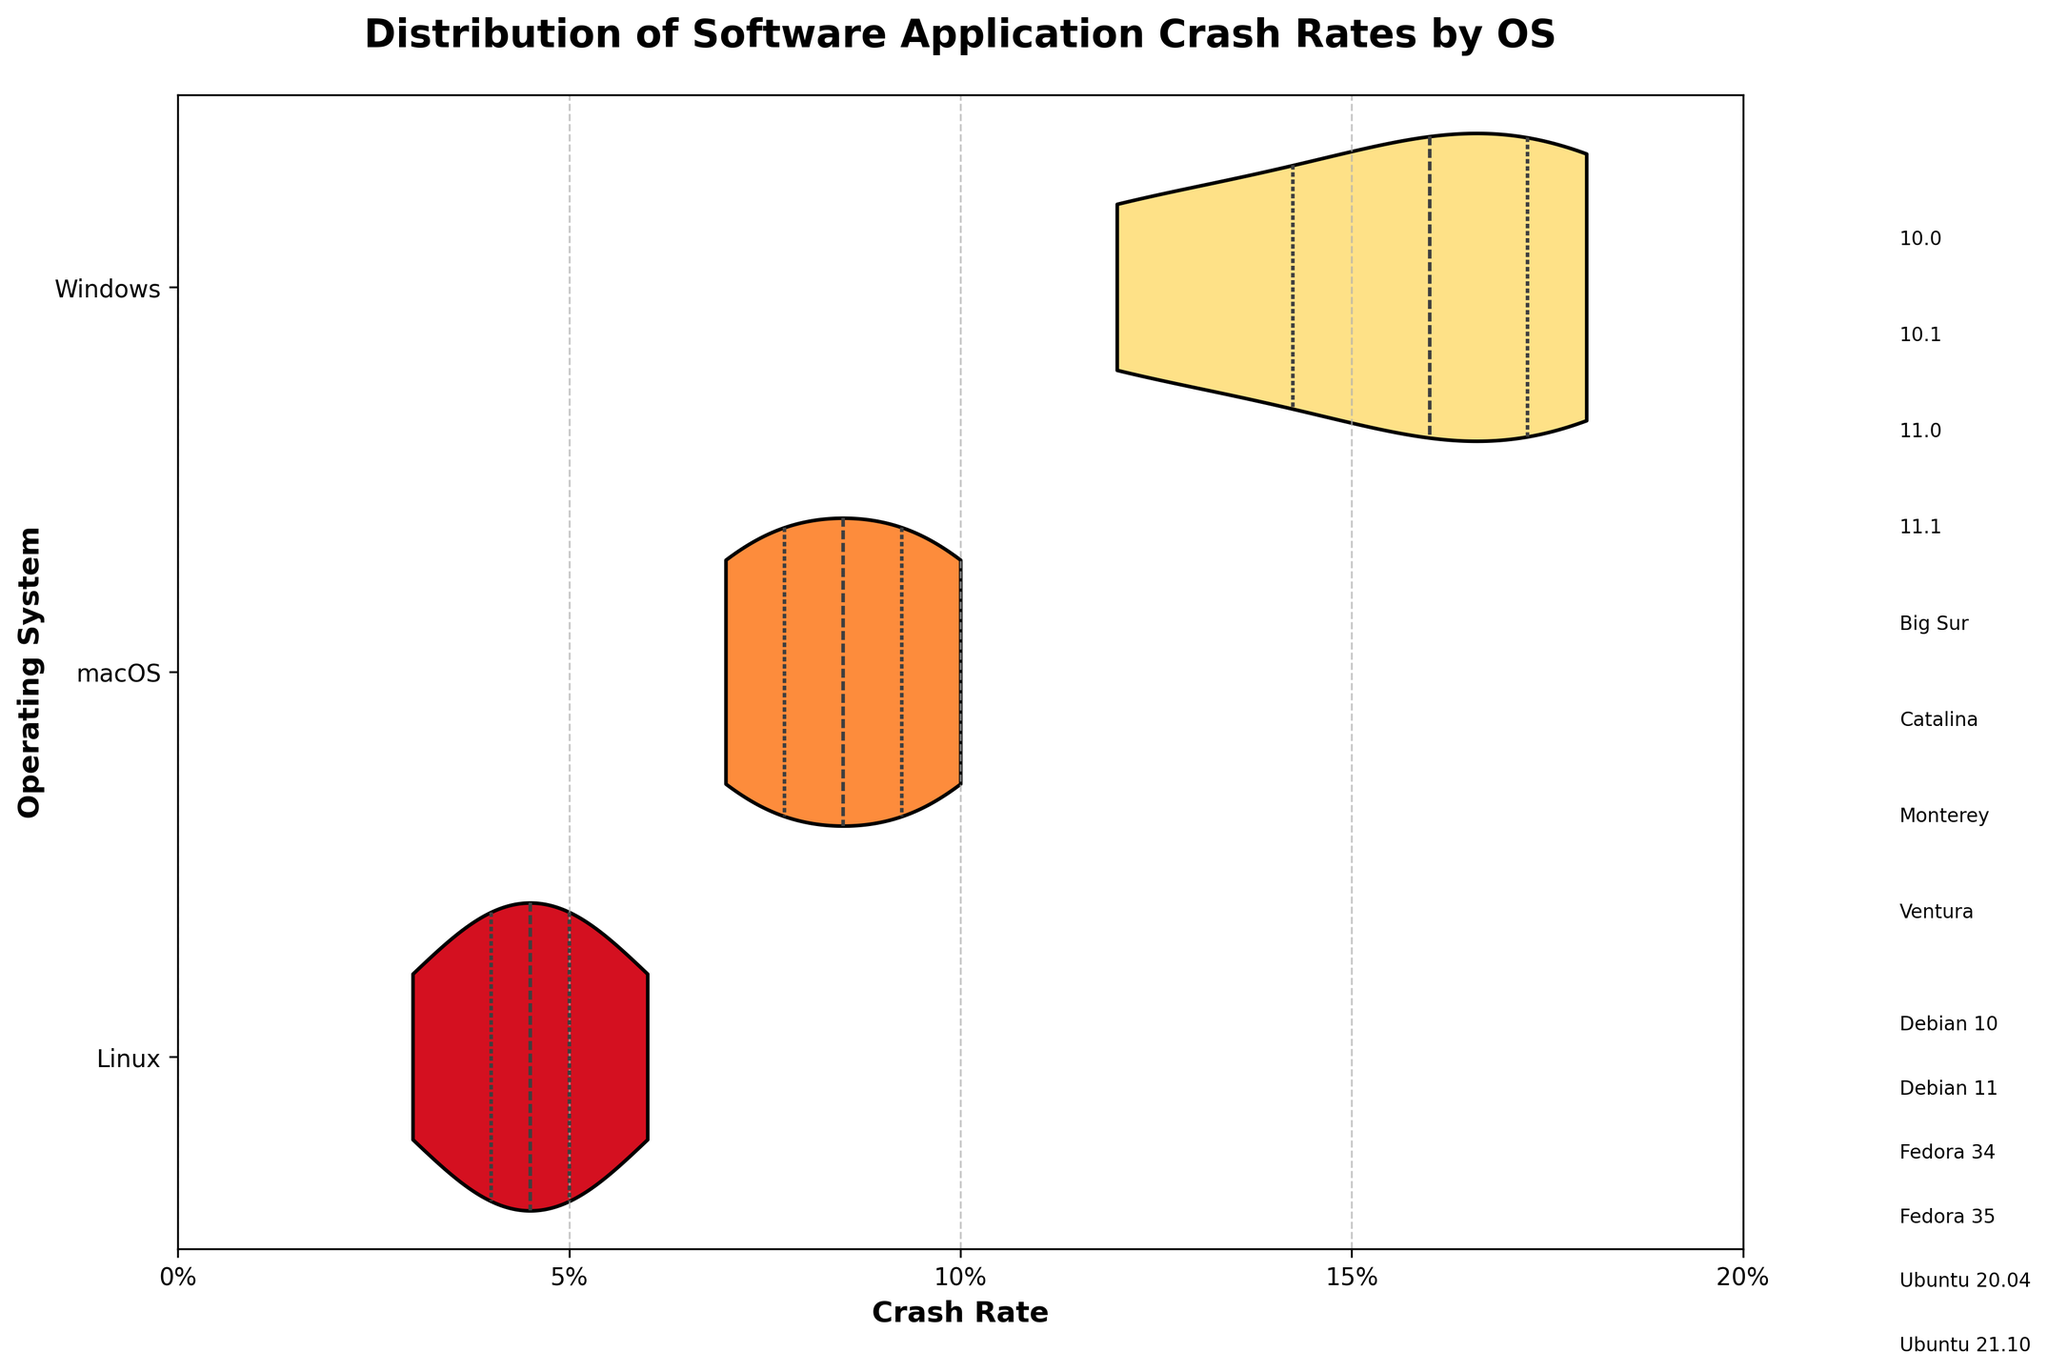What is the title of the plot? The title is usually mentioned at the top of the plot. In this case, it says "Distribution of Software Application Crash Rates by OS".
Answer: Distribution of Software Application Crash Rates by OS Which operating system has the lowest median crash rate? The violin plots usually indicate the median with a line inside the plot. Here, the macOS plot appears to have the lowest median crash rate.
Answer: macOS What is the range of crash rates for Linux? The range can be determined by looking at the width of the Linux violin plot. It spans from approximately 0.03 to 0.06.
Answer: 0.03 to 0.06 Which version of macOS has the lowest crash rate? Each version is labeled near the plot. The version with the lowest crash rate appears to be macOS Ventura.
Answer: Ventura How do the crash rates for Windows 10.1 and Windows 11.0 compare? By checking their positions within the Windows violin plot, Windows 11.0 has a slightly higher crash rate than Windows 10.1.
Answer: Windows 11.0 is higher Which operating system shows the most variation in crash rates? The width of the violin plots indicates the variation. The Windows plot is the widest, showing it has the most variation in crash rates.
Answer: Windows What is the upper quartile of crash rates for macOS? The upper quartile can be found by looking at the upper portion of the macOS violin plot, which seems to be around 0.10.
Answer: ~0.10 Are there more versions listed under Linux or under Windows? Count the number of version labels next to each respective violin plot. Linux has more versions listed (6 compared to Windows' 4).
Answer: Linux has more versions Which operating system has the highest crash rate, and what is the value? The peak of the Windows violin plot appears to be the highest overall, reaching up to 0.18 for Windows 11.0.
Answer: Windows (0.18) How does the average crash rate for Linux compare to the average crash rate for macOS? Considering the spread and heights of the violin plots for both OSes, Linux's plot is narrower and shifted lower than macOS, indicating a generally lower average crash rate for Linux.
Answer: Linux has a lower average 